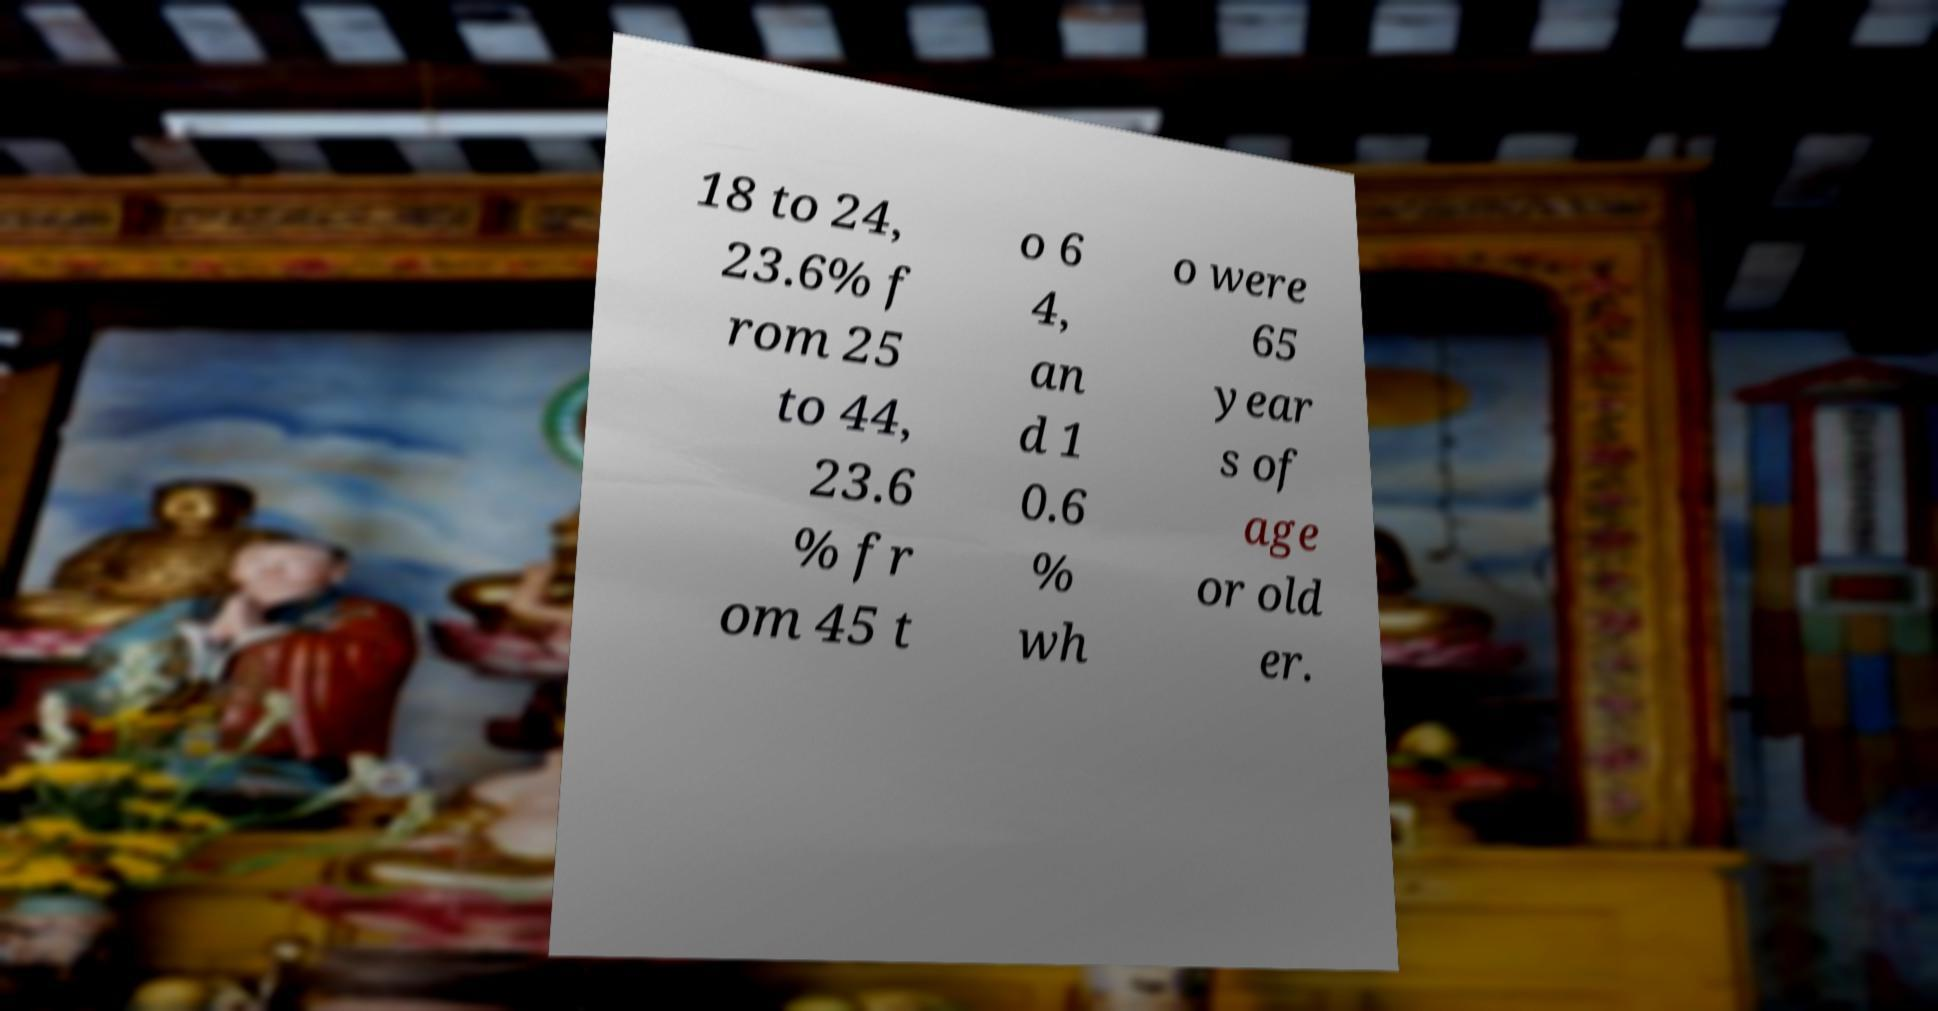There's text embedded in this image that I need extracted. Can you transcribe it verbatim? 18 to 24, 23.6% f rom 25 to 44, 23.6 % fr om 45 t o 6 4, an d 1 0.6 % wh o were 65 year s of age or old er. 